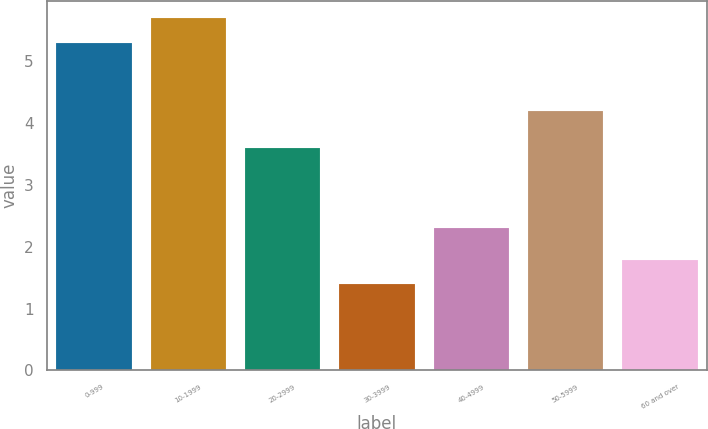Convert chart. <chart><loc_0><loc_0><loc_500><loc_500><bar_chart><fcel>0-999<fcel>10-1999<fcel>20-2999<fcel>30-3999<fcel>40-4999<fcel>50-5999<fcel>60 and over<nl><fcel>5.3<fcel>5.69<fcel>3.6<fcel>1.4<fcel>2.3<fcel>4.2<fcel>1.79<nl></chart> 